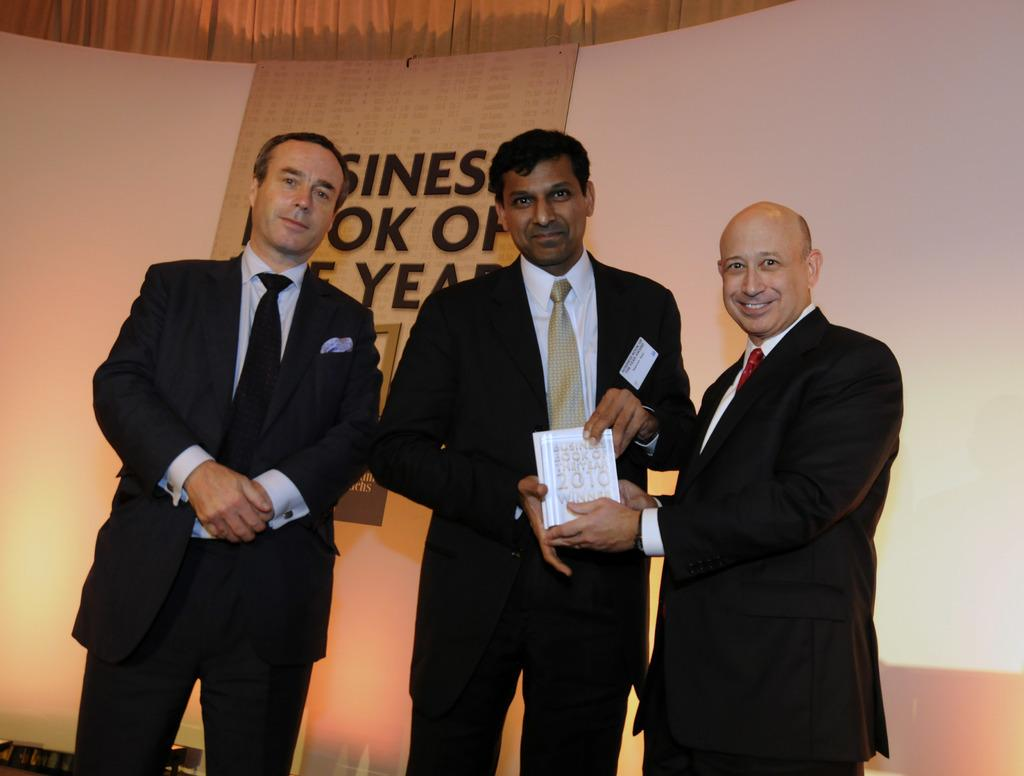How many people are present in the image? There are three people standing in the image. What are two of the people holding? Two of the people are holding a book. What type of lettuce can be seen in the image? There is no lettuce present in the image. How many bells are ringing in the background of the image? There are no bells present in the image, and no sounds are mentioned. 